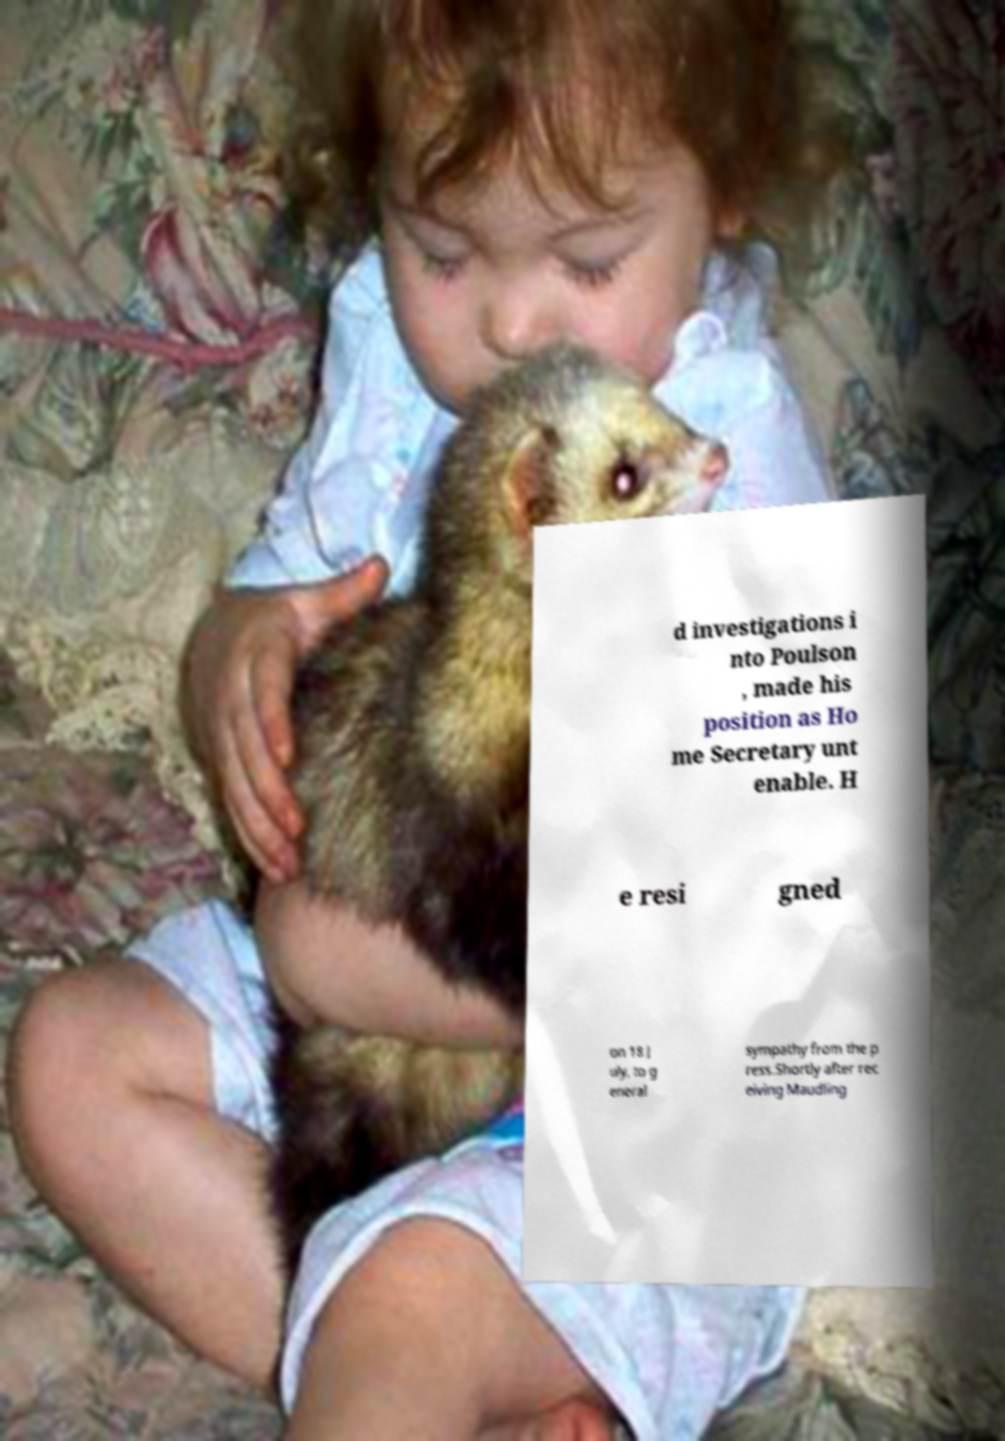Can you read and provide the text displayed in the image?This photo seems to have some interesting text. Can you extract and type it out for me? d investigations i nto Poulson , made his position as Ho me Secretary unt enable. H e resi gned on 18 J uly, to g eneral sympathy from the p ress.Shortly after rec eiving Maudling 